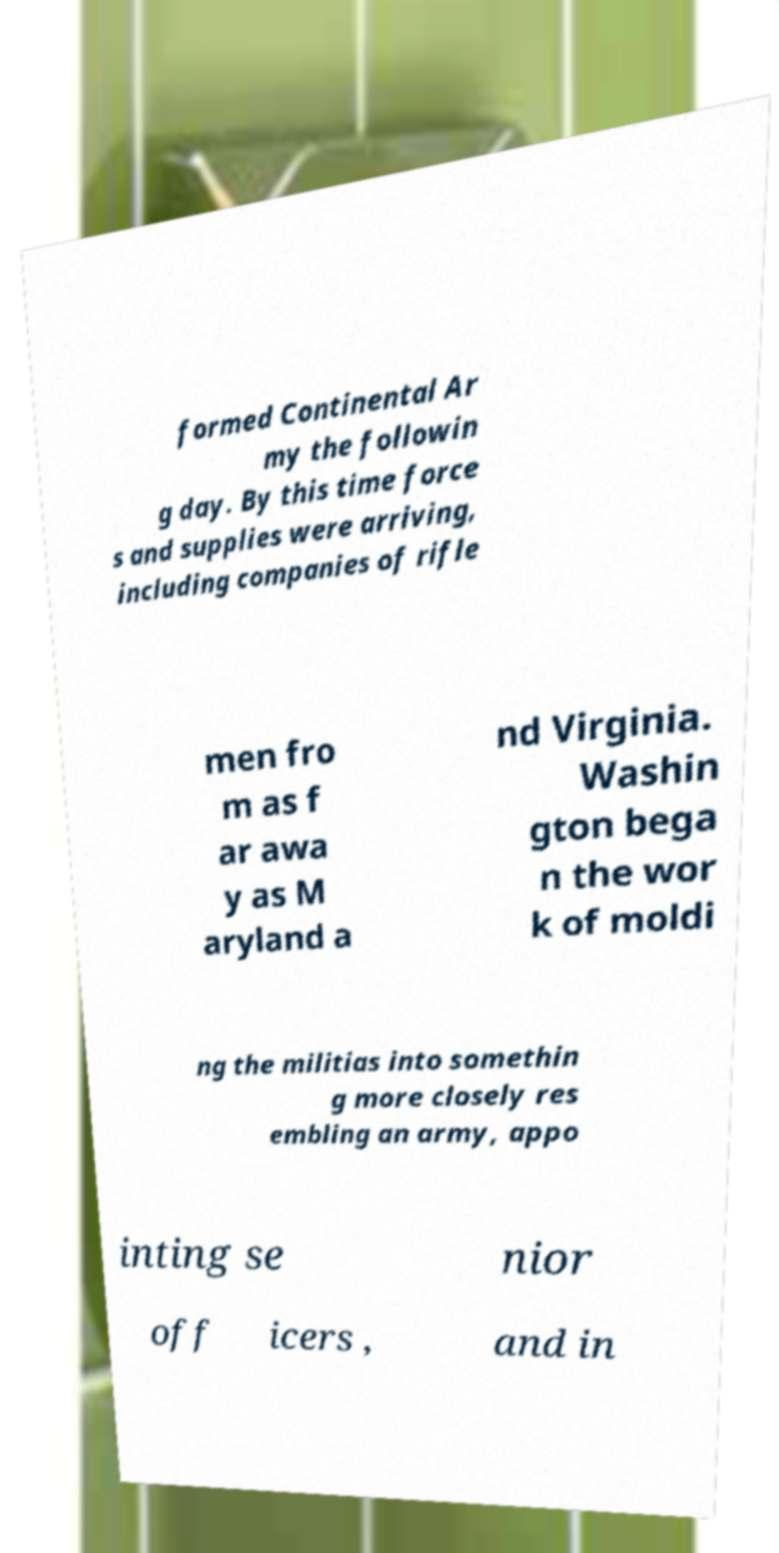Could you assist in decoding the text presented in this image and type it out clearly? formed Continental Ar my the followin g day. By this time force s and supplies were arriving, including companies of rifle men fro m as f ar awa y as M aryland a nd Virginia. Washin gton bega n the wor k of moldi ng the militias into somethin g more closely res embling an army, appo inting se nior off icers , and in 